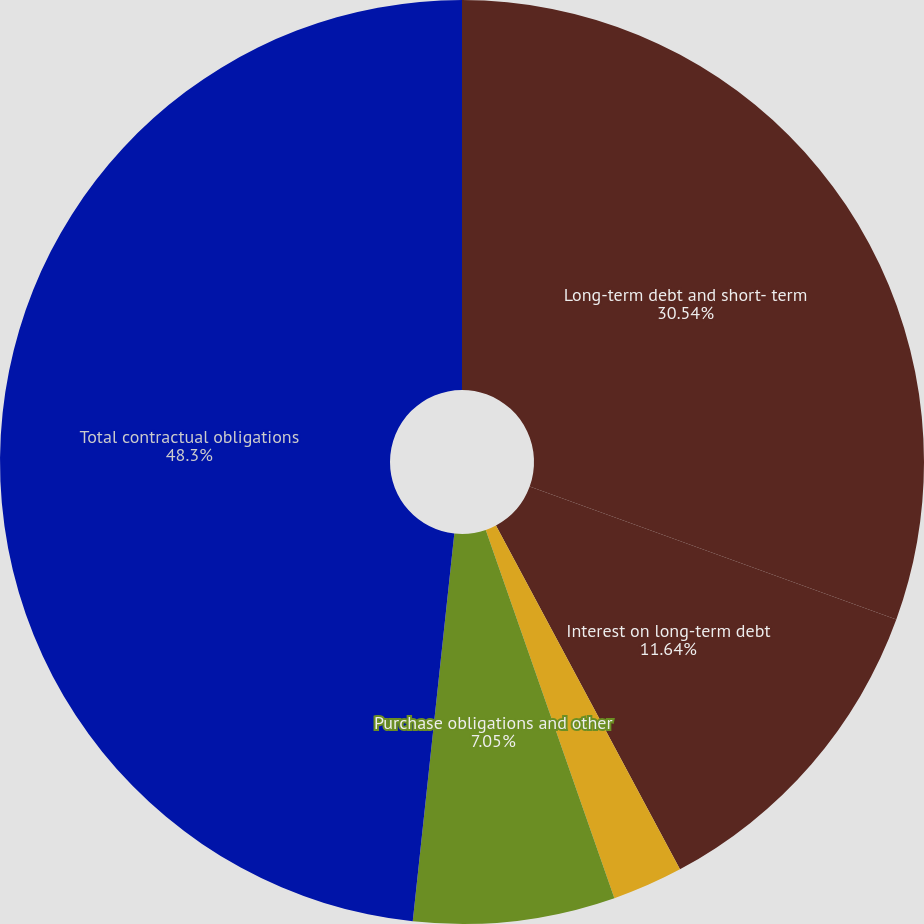Convert chart to OTSL. <chart><loc_0><loc_0><loc_500><loc_500><pie_chart><fcel>Long-term debt and short- term<fcel>Interest on long-term debt<fcel>Operating leases (3)<fcel>Purchase obligations and other<fcel>Total contractual obligations<nl><fcel>30.54%<fcel>11.64%<fcel>2.47%<fcel>7.05%<fcel>48.3%<nl></chart> 